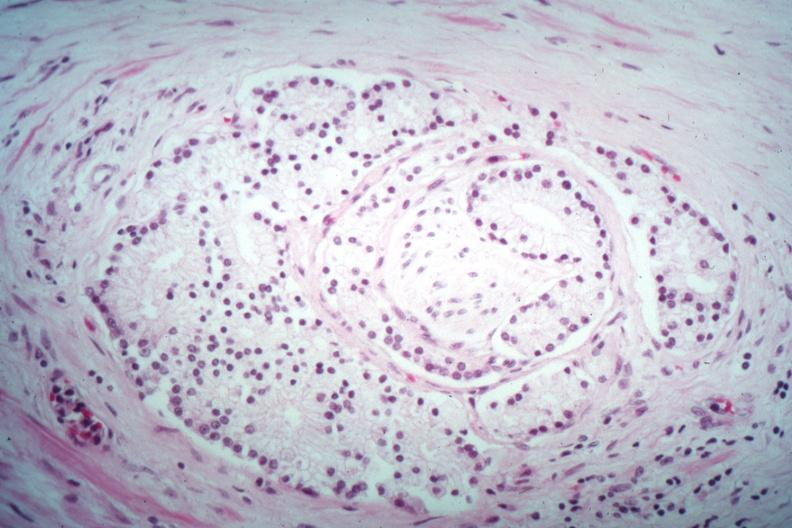s prostate present?
Answer the question using a single word or phrase. Yes 